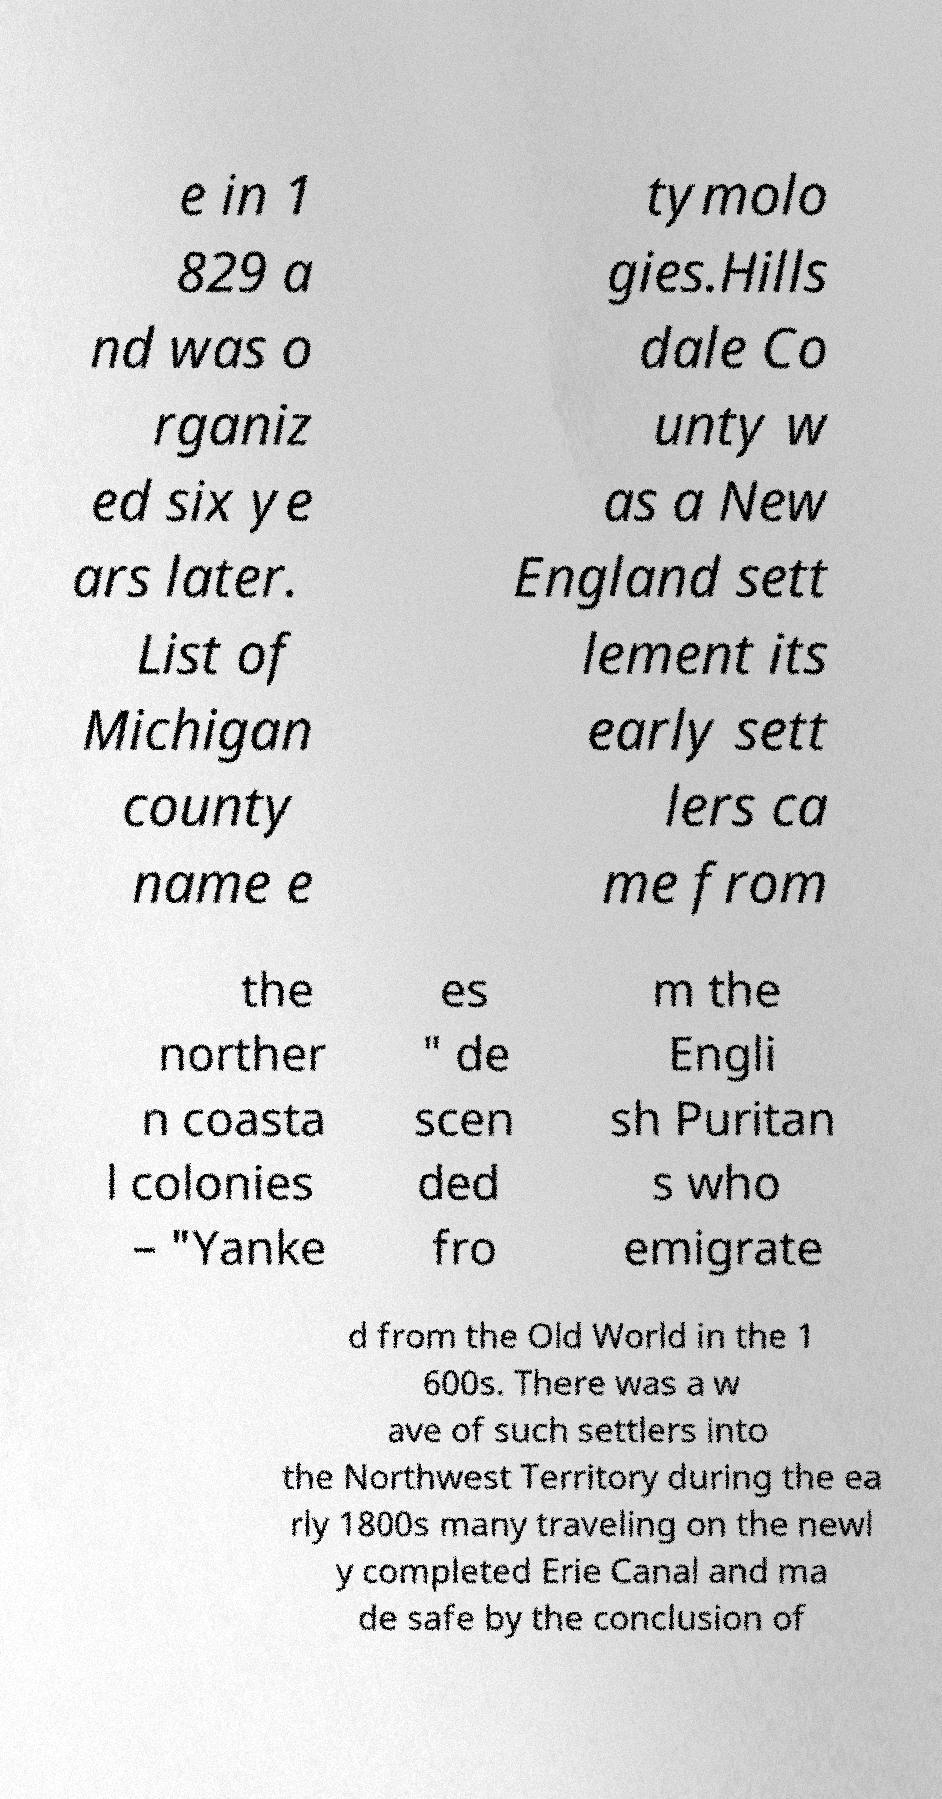Could you assist in decoding the text presented in this image and type it out clearly? e in 1 829 a nd was o rganiz ed six ye ars later. List of Michigan county name e tymolo gies.Hills dale Co unty w as a New England sett lement its early sett lers ca me from the norther n coasta l colonies – "Yanke es " de scen ded fro m the Engli sh Puritan s who emigrate d from the Old World in the 1 600s. There was a w ave of such settlers into the Northwest Territory during the ea rly 1800s many traveling on the newl y completed Erie Canal and ma de safe by the conclusion of 